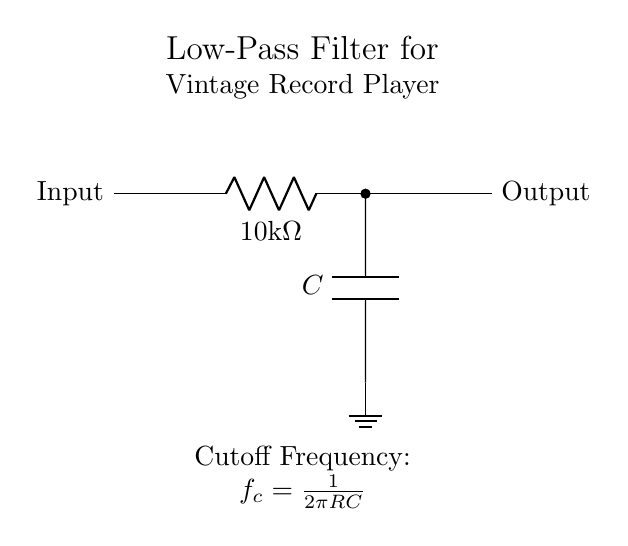What type of filter is shown in the diagram? The diagram depicts a low-pass filter, which allows signals with a frequency lower than a certain cutoff frequency to pass through while attenuating higher frequency signals.
Answer: low-pass filter What is the value of the resistor in this circuit? The resistor is labeled as 10 kΩ, which indicates its resistance value directly on the diagram.
Answer: 10 kΩ What component is connected to ground? The capacitor is the component connected to ground in this circuit, as indicated by the ground symbol next to it in the diagram.
Answer: capacitor What does the cutoff frequency formula represent? The cutoff frequency formula, f_c = 1/(2πRC), expresses the frequency at which the output signal power drops to half of the input signal power, and is derived from the values of the resistor and capacitor.
Answer: frequency equation How does increasing the capacitance affect the cutoff frequency? Increasing the capacitance (C) will lower the cutoff frequency (f_c), as seen in the formula. More capacitance allows lower frequencies to pass through more effectively, thus affecting the filter's behavior.
Answer: decreases What is the purpose of this filter circuit in vintage record players? The purpose is to reduce unwanted high-frequency noise from the audio signal, ensuring that the output sound is clearer and more faithful to the original recording.
Answer: reduce noise 